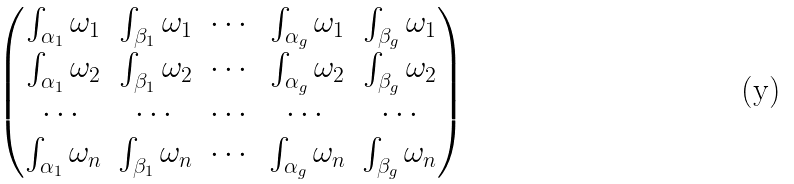Convert formula to latex. <formula><loc_0><loc_0><loc_500><loc_500>\begin{pmatrix} \int _ { \alpha _ { 1 } } \omega _ { 1 } & \int _ { \beta _ { 1 } } \omega _ { 1 } & \cdots & \int _ { \alpha _ { g } } \omega _ { 1 } & \int _ { \beta _ { g } } \omega _ { 1 } \\ \int _ { \alpha _ { 1 } } \omega _ { 2 } & \int _ { \beta _ { 1 } } \omega _ { 2 } & \cdots & \int _ { \alpha _ { g } } \omega _ { 2 } & \int _ { \beta _ { g } } \omega _ { 2 } \\ \cdots & \cdots & \cdots & \cdots & \cdots \\ \int _ { \alpha _ { 1 } } \omega _ { n } & \int _ { \beta _ { 1 } } \omega _ { n } & \cdots & \int _ { \alpha _ { g } } \omega _ { n } & \int _ { \beta _ { g } } \omega _ { n } \end{pmatrix}</formula> 